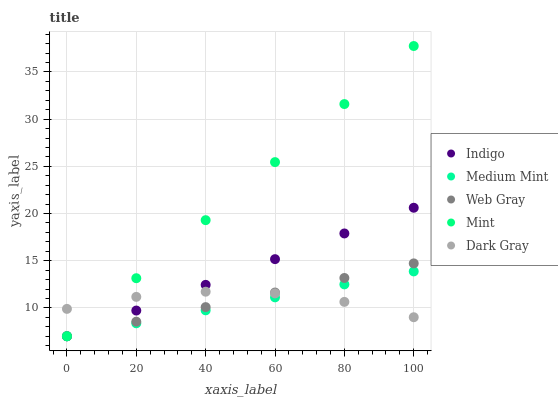Does Medium Mint have the minimum area under the curve?
Answer yes or no. Yes. Does Mint have the maximum area under the curve?
Answer yes or no. Yes. Does Web Gray have the minimum area under the curve?
Answer yes or no. No. Does Web Gray have the maximum area under the curve?
Answer yes or no. No. Is Medium Mint the smoothest?
Answer yes or no. Yes. Is Dark Gray the roughest?
Answer yes or no. Yes. Is Mint the smoothest?
Answer yes or no. No. Is Mint the roughest?
Answer yes or no. No. Does Medium Mint have the lowest value?
Answer yes or no. Yes. Does Dark Gray have the lowest value?
Answer yes or no. No. Does Mint have the highest value?
Answer yes or no. Yes. Does Web Gray have the highest value?
Answer yes or no. No. Does Indigo intersect Mint?
Answer yes or no. Yes. Is Indigo less than Mint?
Answer yes or no. No. Is Indigo greater than Mint?
Answer yes or no. No. 